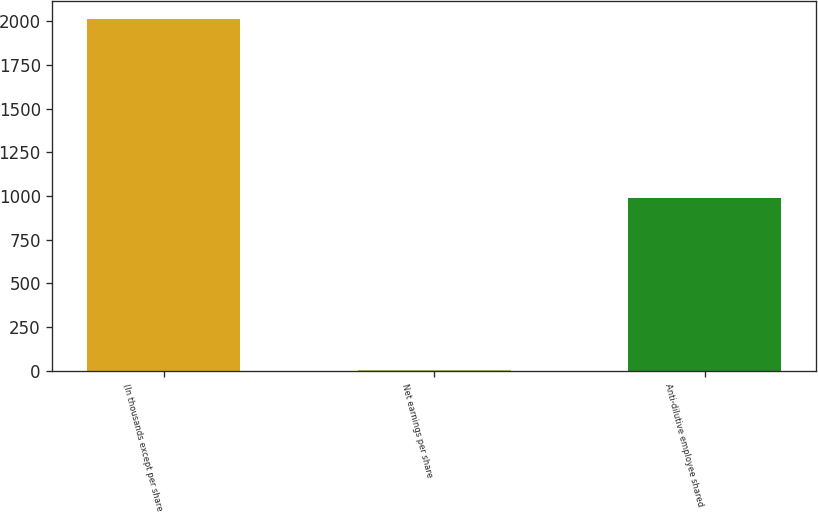Convert chart. <chart><loc_0><loc_0><loc_500><loc_500><bar_chart><fcel>(In thousands except per share<fcel>Net earnings per share<fcel>Anti-dilutive employee shared<nl><fcel>2015<fcel>4.09<fcel>987<nl></chart> 